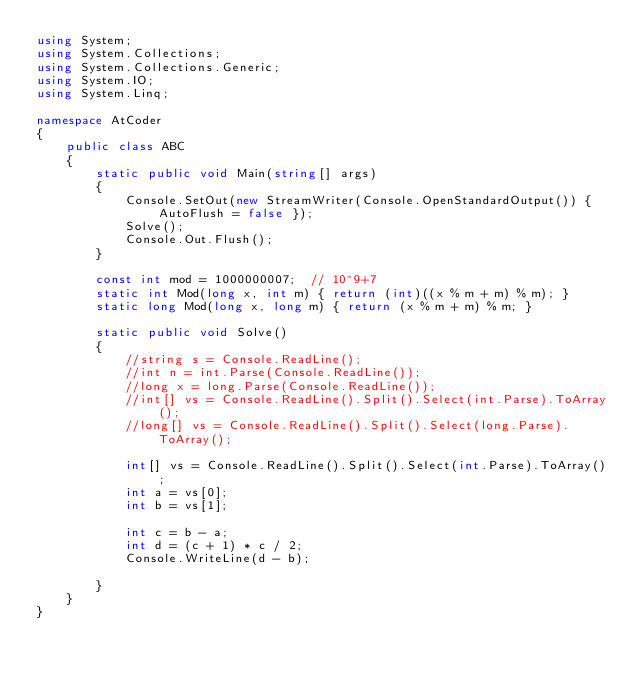Convert code to text. <code><loc_0><loc_0><loc_500><loc_500><_C#_>using System;
using System.Collections;
using System.Collections.Generic;
using System.IO;
using System.Linq;

namespace AtCoder
{
	public class ABC
	{
		static public void Main(string[] args)
		{
			Console.SetOut(new StreamWriter(Console.OpenStandardOutput()) { AutoFlush = false });
			Solve();
			Console.Out.Flush();
		}

		const int mod = 1000000007;  // 10^9+7
		static int Mod(long x, int m) { return (int)((x % m + m) % m); }
		static long Mod(long x, long m) { return (x % m + m) % m; }

		static public void Solve()
		{
			//string s = Console.ReadLine();
			//int n = int.Parse(Console.ReadLine());
			//long x = long.Parse(Console.ReadLine());
			//int[] vs = Console.ReadLine().Split().Select(int.Parse).ToArray();
			//long[] vs = Console.ReadLine().Split().Select(long.Parse).ToArray();

			int[] vs = Console.ReadLine().Split().Select(int.Parse).ToArray();
			int a = vs[0];
			int b = vs[1];

			int c = b - a;
			int d = (c + 1) * c / 2;
			Console.WriteLine(d - b);

		}
	}
}
</code> 